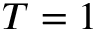Convert formula to latex. <formula><loc_0><loc_0><loc_500><loc_500>T = 1</formula> 